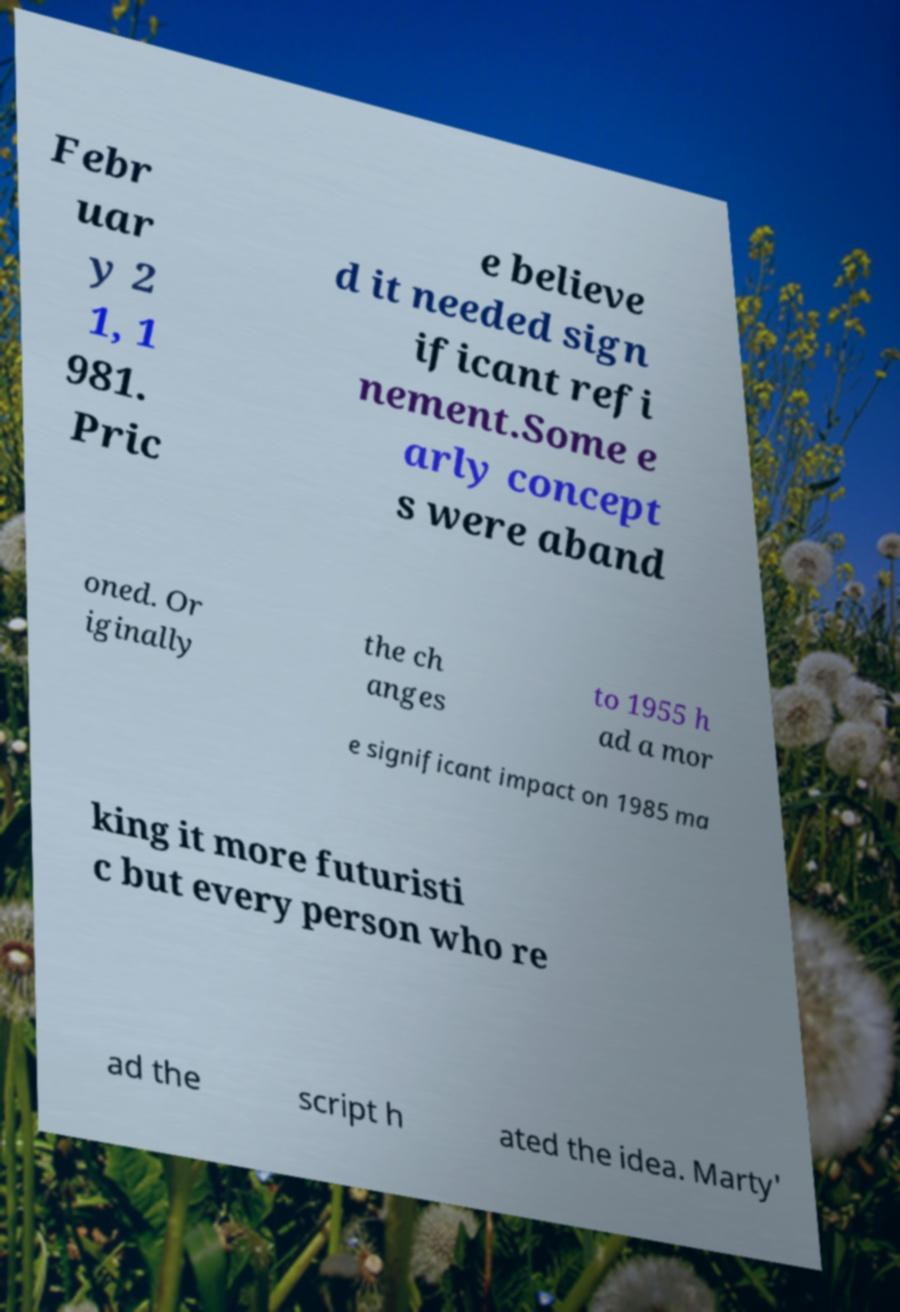Could you assist in decoding the text presented in this image and type it out clearly? Febr uar y 2 1, 1 981. Pric e believe d it needed sign ificant refi nement.Some e arly concept s were aband oned. Or iginally the ch anges to 1955 h ad a mor e significant impact on 1985 ma king it more futuristi c but every person who re ad the script h ated the idea. Marty' 